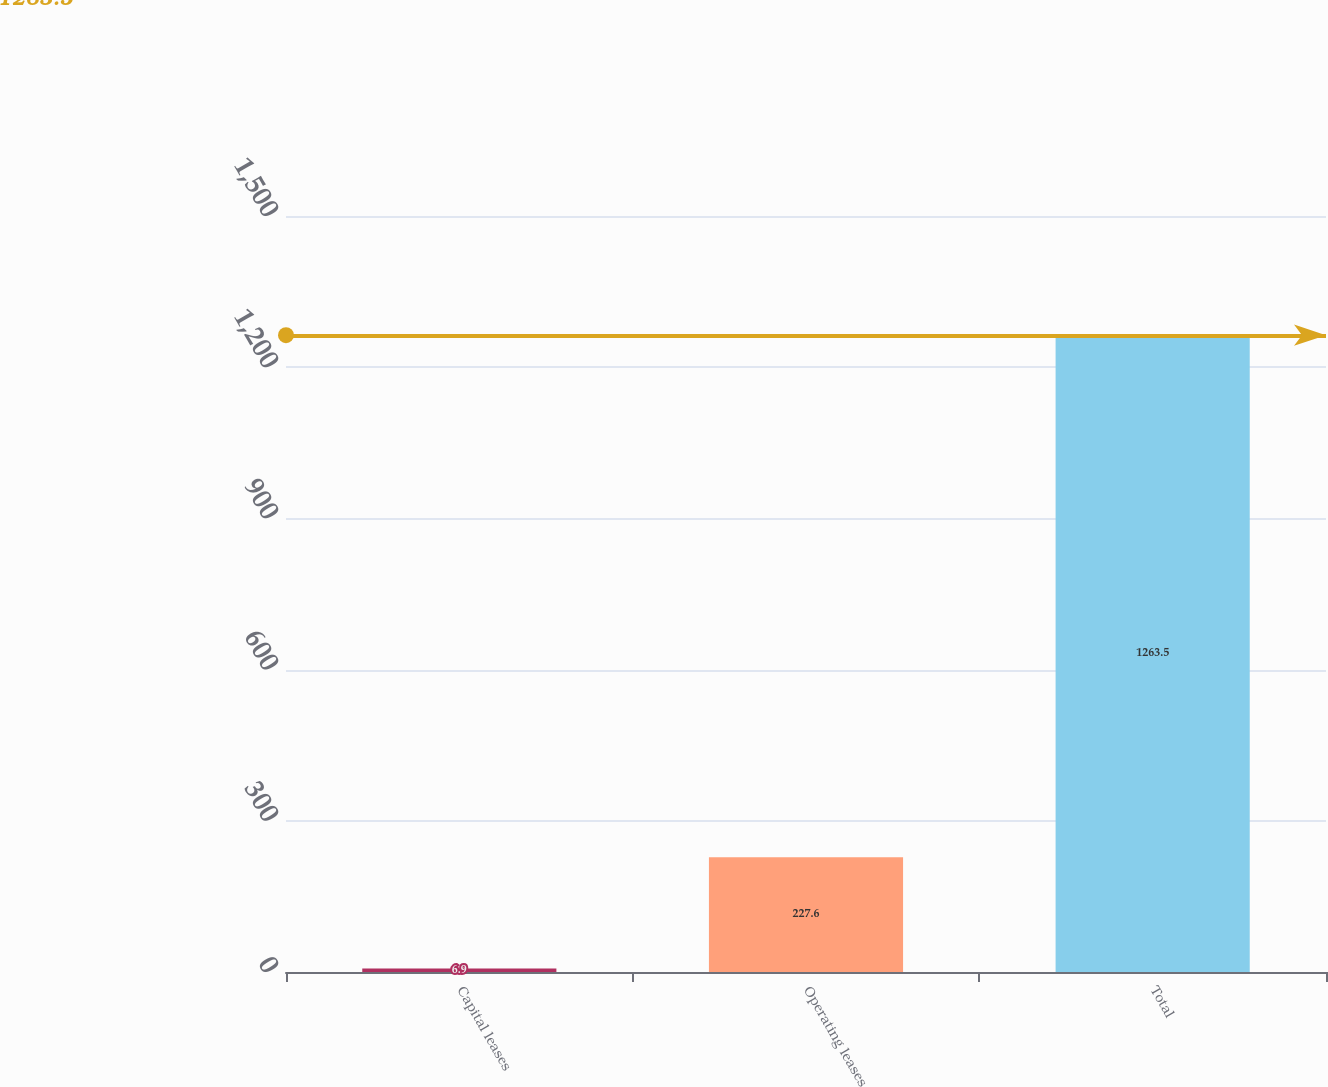<chart> <loc_0><loc_0><loc_500><loc_500><bar_chart><fcel>Capital leases<fcel>Operating leases<fcel>Total<nl><fcel>6.9<fcel>227.6<fcel>1263.5<nl></chart> 